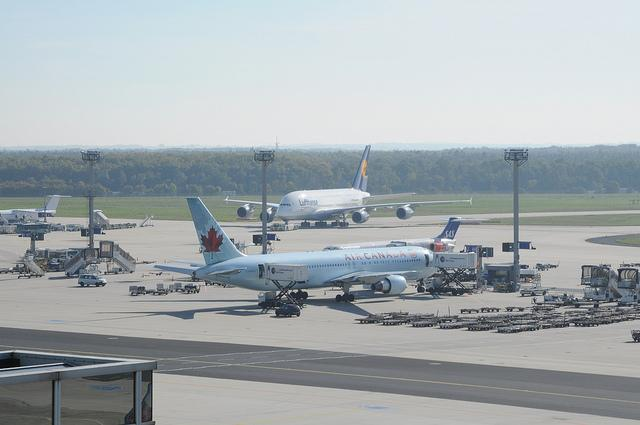What continent is the plane in the foreground from? north america 